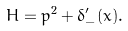<formula> <loc_0><loc_0><loc_500><loc_500>H = p ^ { 2 } + \delta _ { - } ^ { \prime } ( x ) .</formula> 